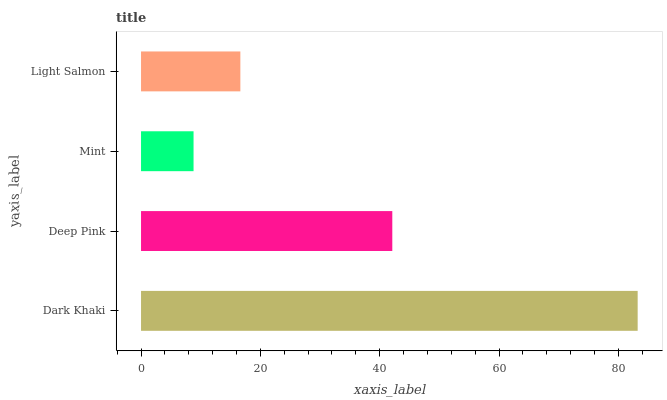Is Mint the minimum?
Answer yes or no. Yes. Is Dark Khaki the maximum?
Answer yes or no. Yes. Is Deep Pink the minimum?
Answer yes or no. No. Is Deep Pink the maximum?
Answer yes or no. No. Is Dark Khaki greater than Deep Pink?
Answer yes or no. Yes. Is Deep Pink less than Dark Khaki?
Answer yes or no. Yes. Is Deep Pink greater than Dark Khaki?
Answer yes or no. No. Is Dark Khaki less than Deep Pink?
Answer yes or no. No. Is Deep Pink the high median?
Answer yes or no. Yes. Is Light Salmon the low median?
Answer yes or no. Yes. Is Light Salmon the high median?
Answer yes or no. No. Is Deep Pink the low median?
Answer yes or no. No. 